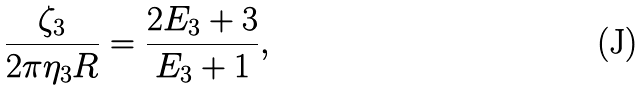<formula> <loc_0><loc_0><loc_500><loc_500>\frac { \zeta _ { 3 } } { 2 \pi \eta _ { 3 } R } = \frac { 2 E _ { 3 } + 3 } { E _ { 3 } + 1 } ,</formula> 